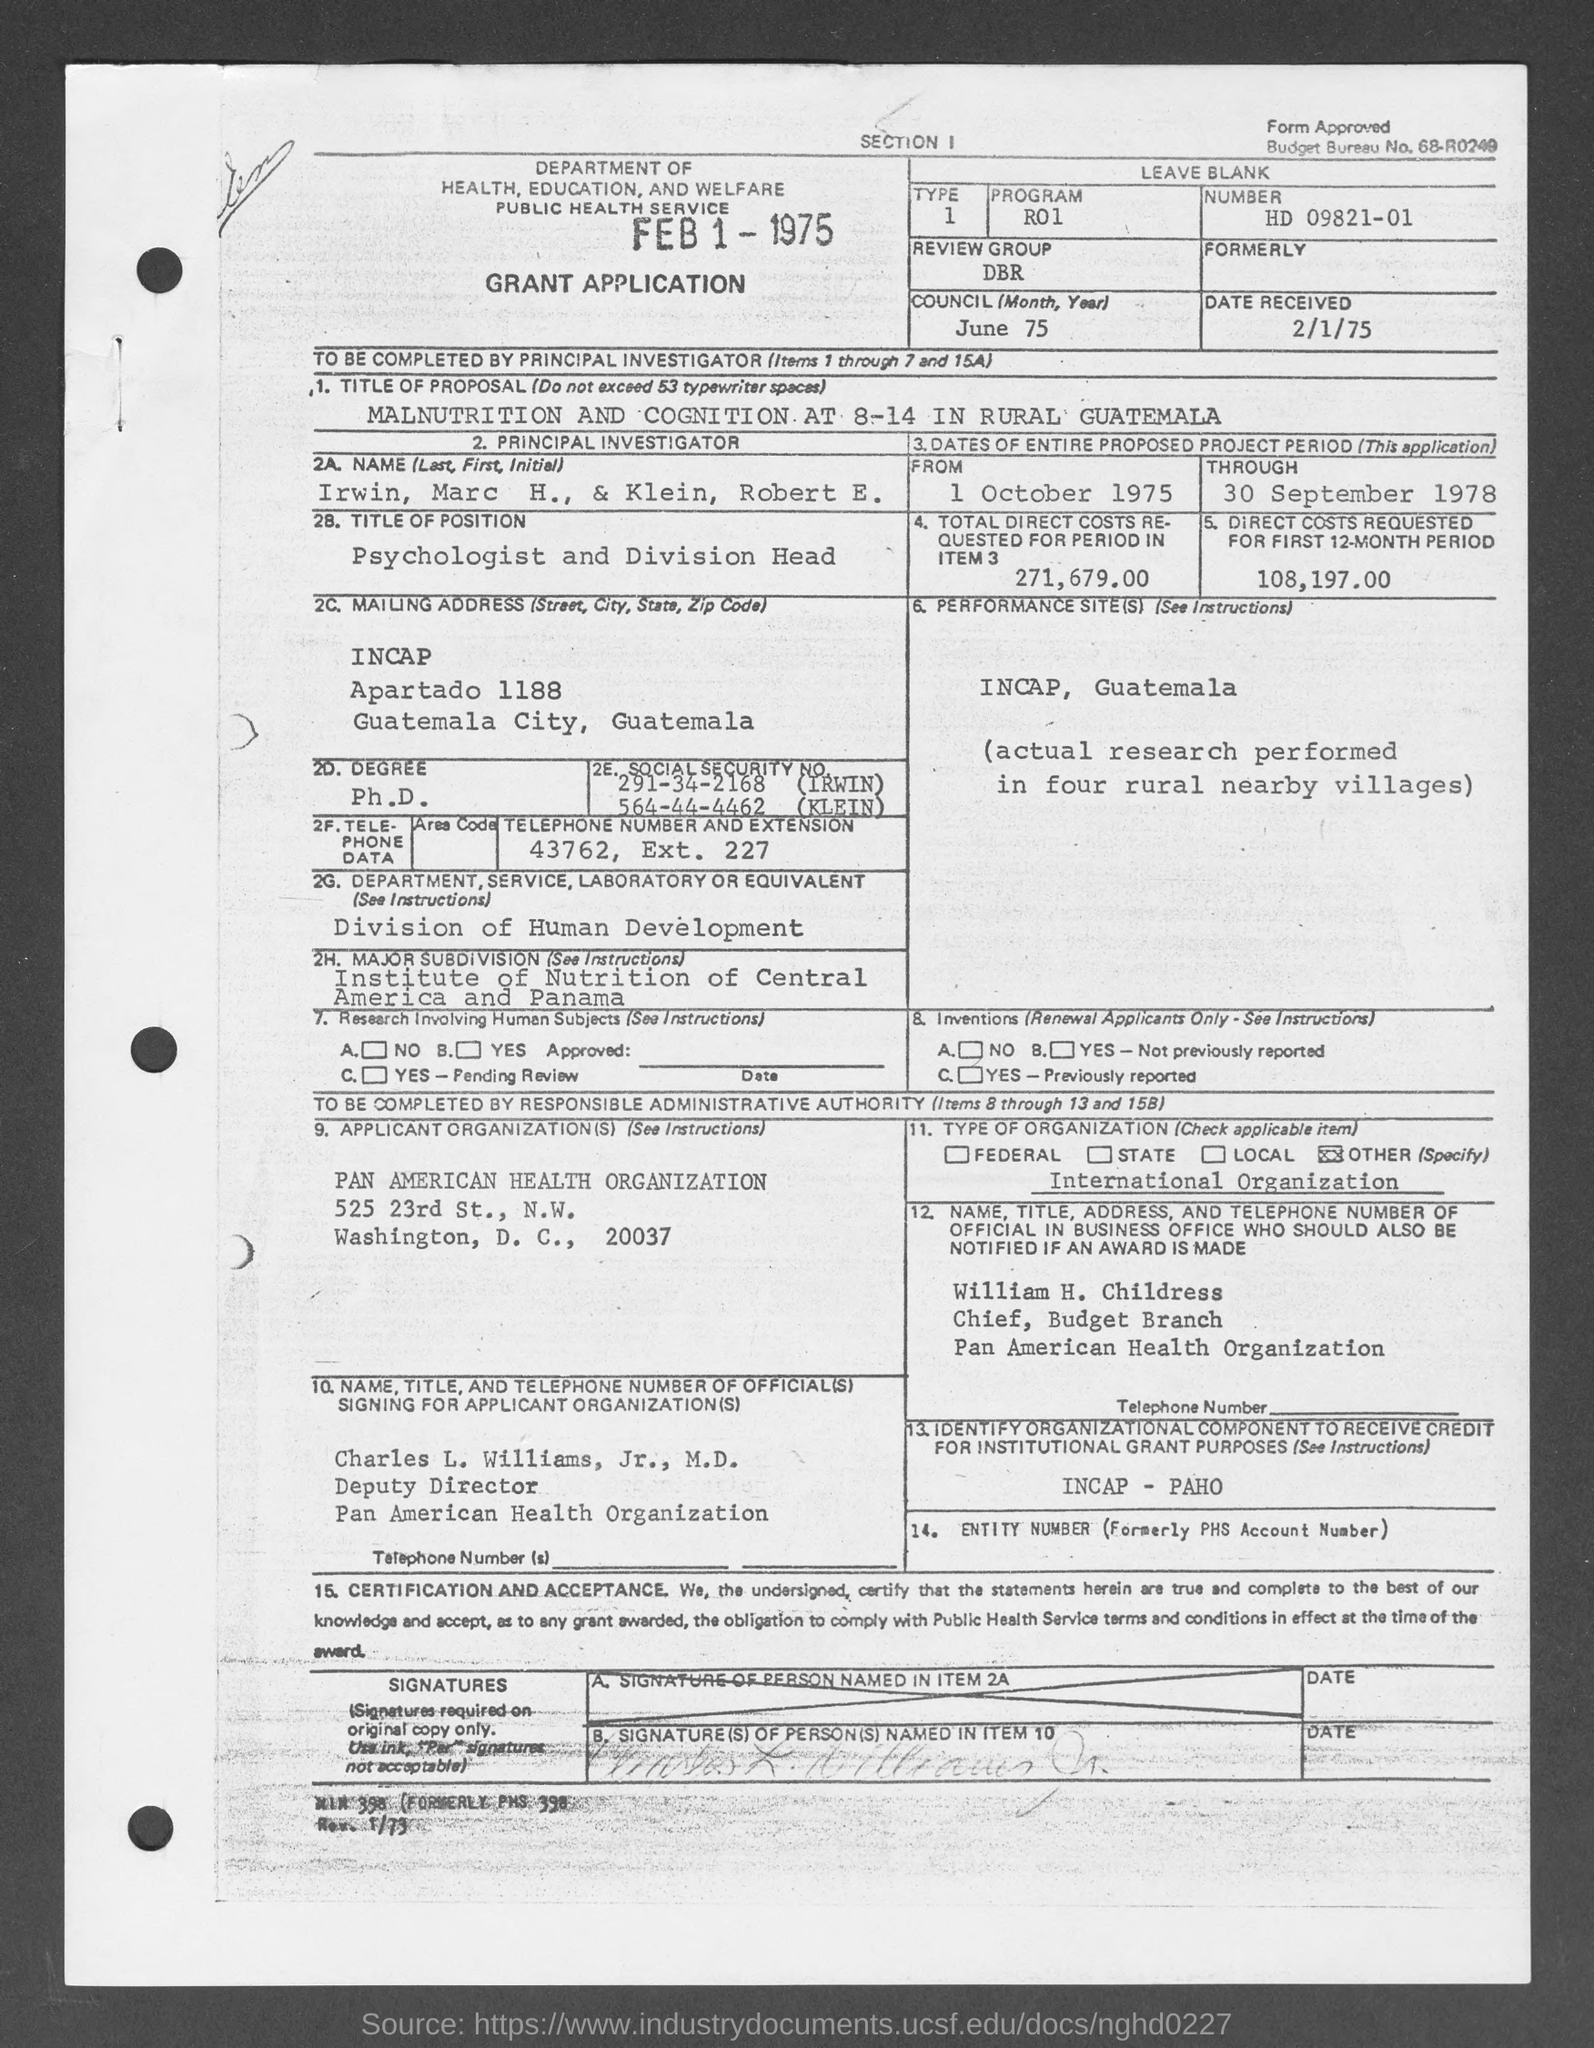Mention a couple of crucial points in this snapshot. The total direct costs requested for the specified period are $271,679.00. The "From" date is 1 October 1975. The date received is February 1, 1975. The Review Group, commonly referred to as DBR, is a committee responsible for reviewing and providing feedback on the quality of work produced by the Development Team. The through date is September 30, 1978. 